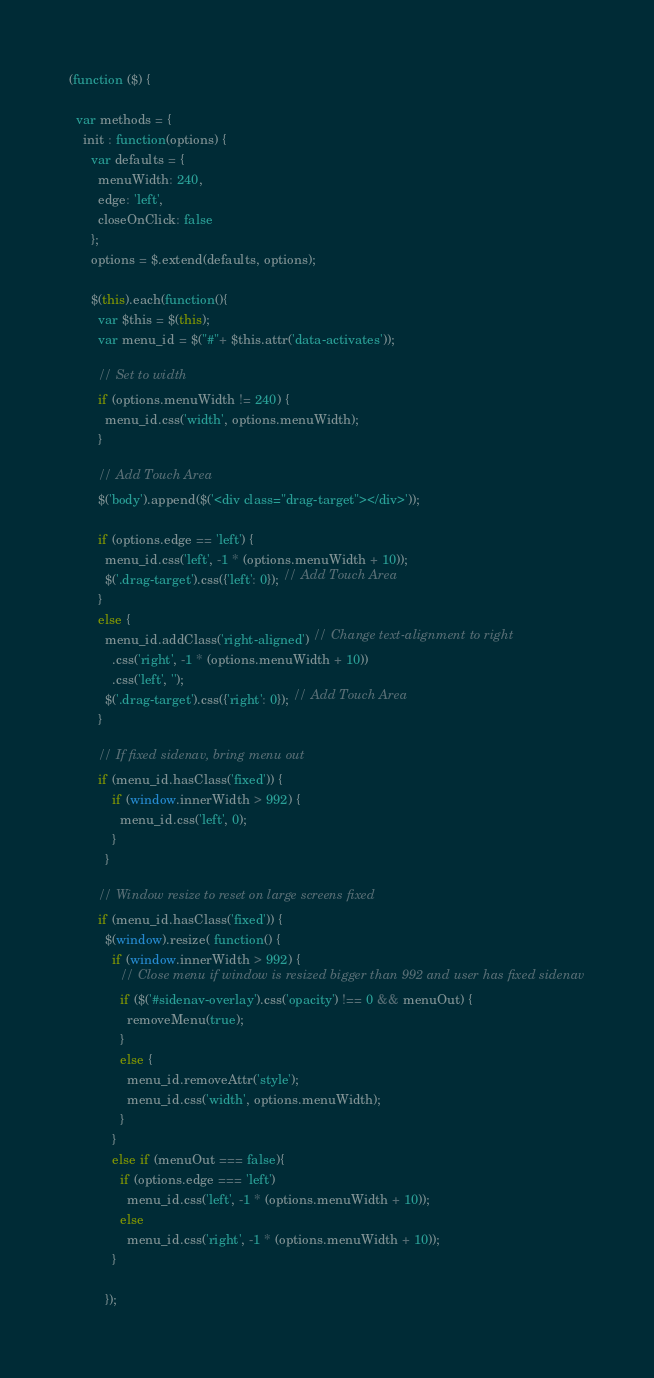Convert code to text. <code><loc_0><loc_0><loc_500><loc_500><_JavaScript_>(function ($) {

  var methods = {
    init : function(options) {
      var defaults = {
        menuWidth: 240,
        edge: 'left',
        closeOnClick: false
      };
      options = $.extend(defaults, options);

      $(this).each(function(){
        var $this = $(this);
        var menu_id = $("#"+ $this.attr('data-activates'));

        // Set to width
        if (options.menuWidth != 240) {
          menu_id.css('width', options.menuWidth);
        }

        // Add Touch Area
        $('body').append($('<div class="drag-target"></div>'));

        if (options.edge == 'left') {
          menu_id.css('left', -1 * (options.menuWidth + 10));
          $('.drag-target').css({'left': 0}); // Add Touch Area
        }
        else {
          menu_id.addClass('right-aligned') // Change text-alignment to right
            .css('right', -1 * (options.menuWidth + 10))
            .css('left', '');
          $('.drag-target').css({'right': 0}); // Add Touch Area
        }

        // If fixed sidenav, bring menu out
        if (menu_id.hasClass('fixed')) {
            if (window.innerWidth > 992) {
              menu_id.css('left', 0);
            }
          }

        // Window resize to reset on large screens fixed
        if (menu_id.hasClass('fixed')) {
          $(window).resize( function() {
            if (window.innerWidth > 992) {
              // Close menu if window is resized bigger than 992 and user has fixed sidenav
              if ($('#sidenav-overlay').css('opacity') !== 0 && menuOut) {
                removeMenu(true);
              }
              else {
                menu_id.removeAttr('style');
                menu_id.css('width', options.menuWidth);
              }
            }
            else if (menuOut === false){
              if (options.edge === 'left')
                menu_id.css('left', -1 * (options.menuWidth + 10));
              else
                menu_id.css('right', -1 * (options.menuWidth + 10));
            }

          });</code> 